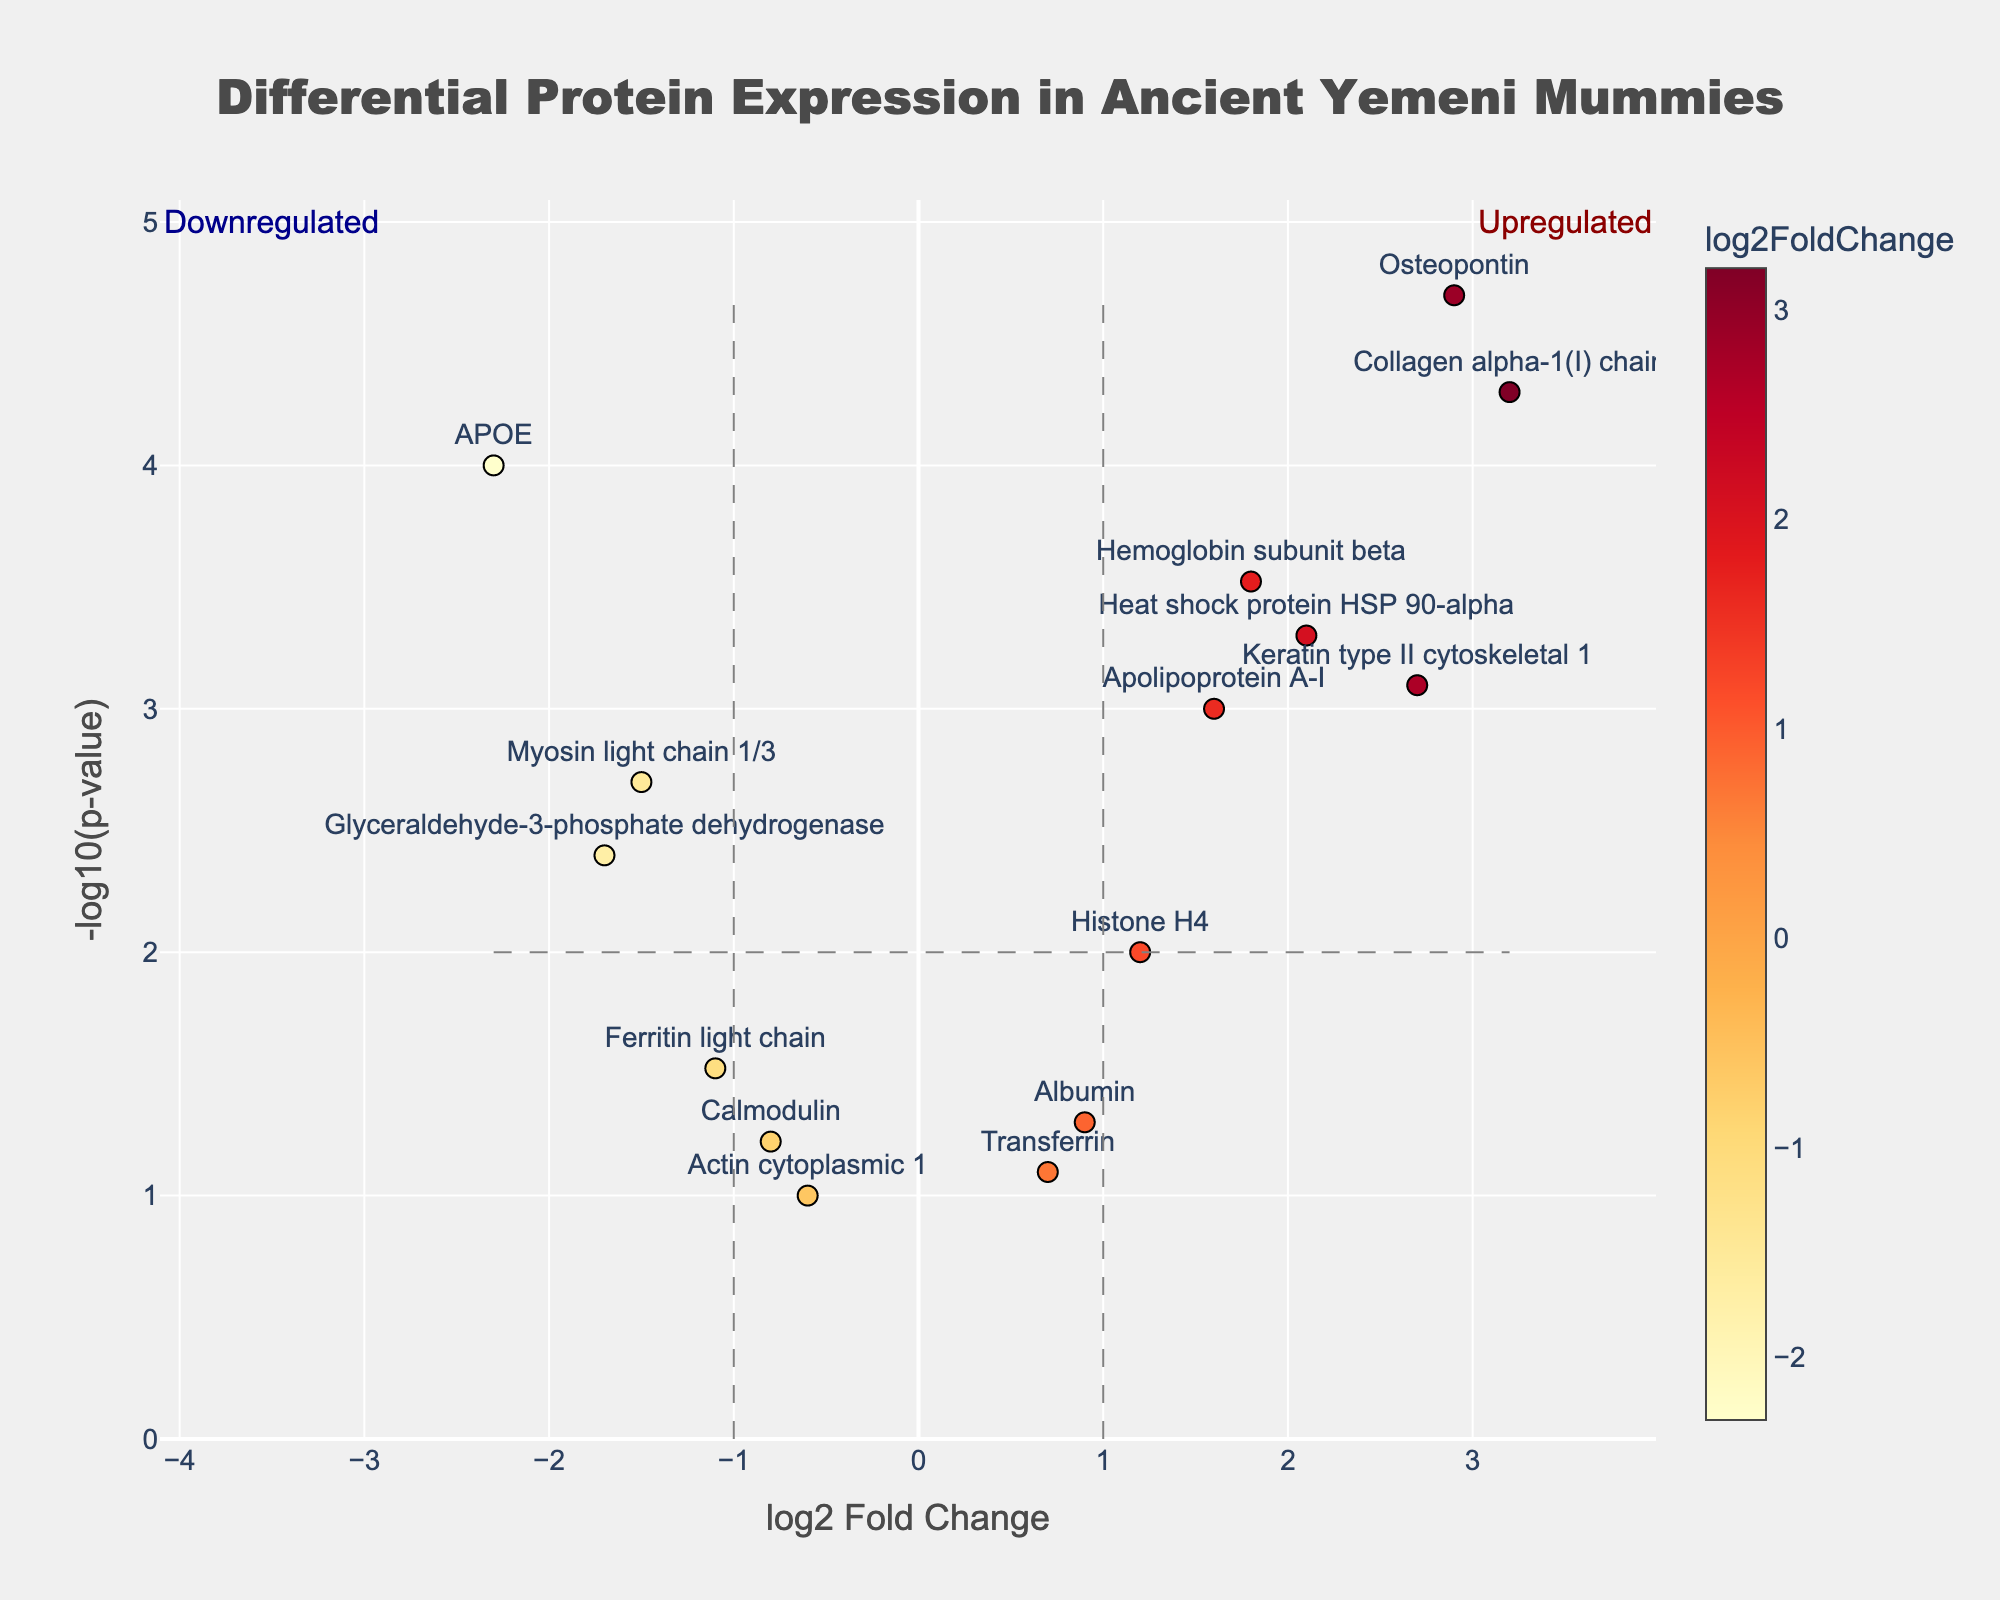What is the title of the figure? The title is typically displayed at the top of the figure to help understand its focus. Here, it indicates what the data represents.
Answer: Differential Protein Expression in Ancient Yemeni Mummies How many proteins are represented in the plot? Count the number of unique protein labels displayed as data points in the figure.
Answer: 15 Which protein has the highest -log10(p-value) and what is its log2 Fold Change? Look for the data point with the highest y-axis value and read its x-axis value to find the log2 Fold Change for that protein.
Answer: Osteopontin, 2.9 Are there any proteins with a log2 Fold Change between 1 and 1.5? If so, name them. Identify the data points positioned between 1 and 1.5 on the x-axis and note their corresponding protein names.
Answer: No How many proteins are significantly upregulated in ancient Yemeni mummies? Count the data points that are above the horizontal threshold line (-log10(p-value) = 2) and to the right of the vertical threshold line (log2FoldChange > 1).
Answer: 6 Which protein is just below the threshold for significance with a log2 Fold Change > 0? Look for a protein that is barely under the horizontal line at -log10(p-value) = 2 but has a log2 Fold Change greater than 0.
Answer: Albumin What is the log2 Fold Change for Myosin light chain 1/3 and is it considered significantly downregulated? Find Myosin light chain 1/3 on the plot, check its position relative to the vertical line at log2FoldChange = -1 and horizontal line at -log10(p-value) = 2.
Answer: -1.5, yes Which protein has the smallest absolute log2 Fold Change? Identify the data point closest to the y-axis (log2 Fold Change of 0) and read its protein name.
Answer: Actin cytoplasmic 1 How does Apolipoprotein A-I compare in terms of significance to Ferritin light chain? Compare the -log10(p-value) values (y-axis) of Apolipoprotein A-I and Ferritin light chain to see which one is higher.
Answer: More significant How many proteins are both significantly upregulated (log2FoldChange > 1) and have a p-value < 0.001? Count the data points that are to the right of the vertical line at log2FoldChange > 1 and above the horizontal line at -log10(p-value) > 3.
Answer: 3 